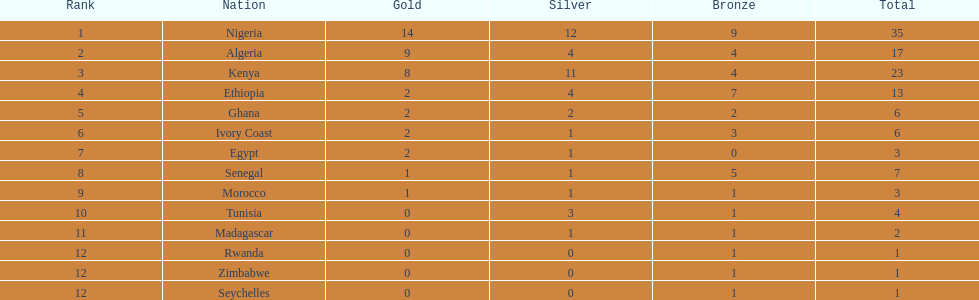How many silver medals were achieved by kenya? 11. 